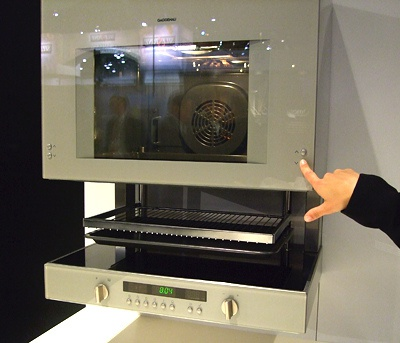Describe the objects in this image and their specific colors. I can see microwave in black, gray, and darkgray tones, people in black, orange, tan, and darkgray tones, and clock in black, darkgreen, gray, and green tones in this image. 